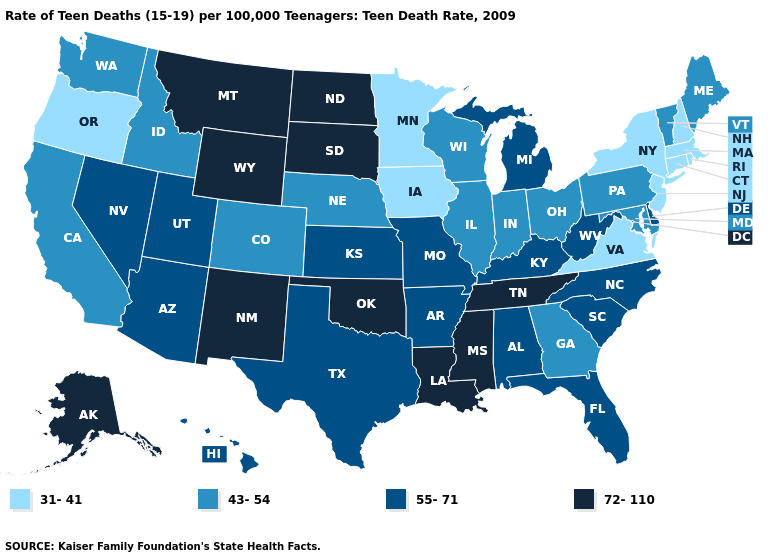What is the value of Alaska?
Write a very short answer. 72-110. Which states have the highest value in the USA?
Write a very short answer. Alaska, Louisiana, Mississippi, Montana, New Mexico, North Dakota, Oklahoma, South Dakota, Tennessee, Wyoming. Name the states that have a value in the range 31-41?
Answer briefly. Connecticut, Iowa, Massachusetts, Minnesota, New Hampshire, New Jersey, New York, Oregon, Rhode Island, Virginia. Among the states that border West Virginia , does Virginia have the highest value?
Be succinct. No. What is the lowest value in states that border Indiana?
Quick response, please. 43-54. What is the value of Missouri?
Give a very brief answer. 55-71. Name the states that have a value in the range 31-41?
Give a very brief answer. Connecticut, Iowa, Massachusetts, Minnesota, New Hampshire, New Jersey, New York, Oregon, Rhode Island, Virginia. Name the states that have a value in the range 72-110?
Answer briefly. Alaska, Louisiana, Mississippi, Montana, New Mexico, North Dakota, Oklahoma, South Dakota, Tennessee, Wyoming. What is the value of California?
Short answer required. 43-54. Among the states that border Tennessee , which have the lowest value?
Concise answer only. Virginia. Does New York have the highest value in the USA?
Quick response, please. No. Does Louisiana have the highest value in the USA?
Be succinct. Yes. What is the lowest value in states that border Rhode Island?
Keep it brief. 31-41. What is the value of South Carolina?
Concise answer only. 55-71. Does the map have missing data?
Quick response, please. No. 